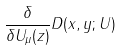Convert formula to latex. <formula><loc_0><loc_0><loc_500><loc_500>\frac { \delta } { \delta U _ { \mu } ( z ) } D ( x , y ; U )</formula> 